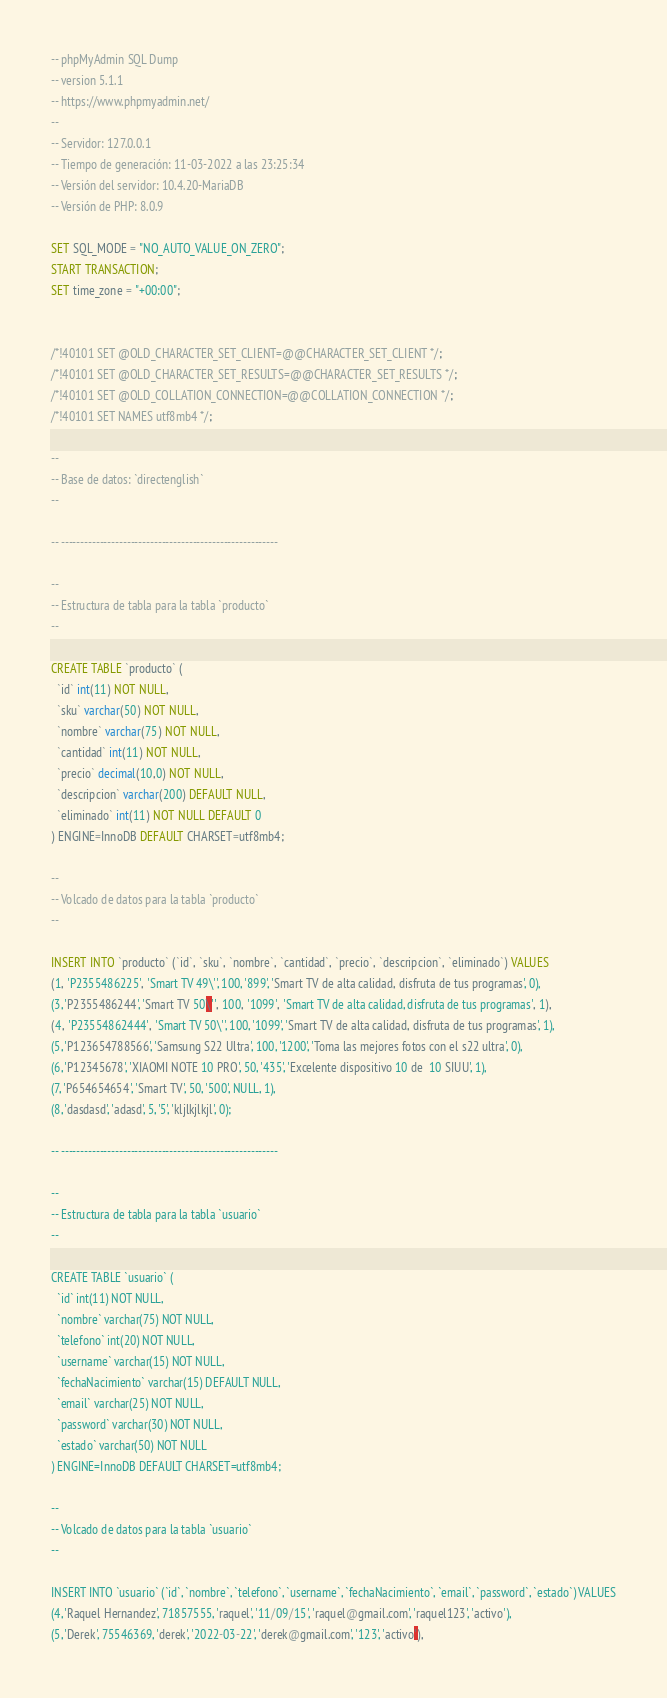Convert code to text. <code><loc_0><loc_0><loc_500><loc_500><_SQL_>-- phpMyAdmin SQL Dump
-- version 5.1.1
-- https://www.phpmyadmin.net/
--
-- Servidor: 127.0.0.1
-- Tiempo de generación: 11-03-2022 a las 23:25:34
-- Versión del servidor: 10.4.20-MariaDB
-- Versión de PHP: 8.0.9

SET SQL_MODE = "NO_AUTO_VALUE_ON_ZERO";
START TRANSACTION;
SET time_zone = "+00:00";


/*!40101 SET @OLD_CHARACTER_SET_CLIENT=@@CHARACTER_SET_CLIENT */;
/*!40101 SET @OLD_CHARACTER_SET_RESULTS=@@CHARACTER_SET_RESULTS */;
/*!40101 SET @OLD_COLLATION_CONNECTION=@@COLLATION_CONNECTION */;
/*!40101 SET NAMES utf8mb4 */;

--
-- Base de datos: `directenglish`
--

-- --------------------------------------------------------

--
-- Estructura de tabla para la tabla `producto`
--

CREATE TABLE `producto` (
  `id` int(11) NOT NULL,
  `sku` varchar(50) NOT NULL,
  `nombre` varchar(75) NOT NULL,
  `cantidad` int(11) NOT NULL,
  `precio` decimal(10,0) NOT NULL,
  `descripcion` varchar(200) DEFAULT NULL,
  `eliminado` int(11) NOT NULL DEFAULT 0
) ENGINE=InnoDB DEFAULT CHARSET=utf8mb4;

--
-- Volcado de datos para la tabla `producto`
--

INSERT INTO `producto` (`id`, `sku`, `nombre`, `cantidad`, `precio`, `descripcion`, `eliminado`) VALUES
(1, 'P2355486225', 'Smart TV 49\'', 100, '899', 'Smart TV de alta calidad, disfruta de tus programas', 0),
(3, 'P2355486244', 'Smart TV 50\'', 100, '1099', 'Smart TV de alta calidad, disfruta de tus programas', 1),
(4, 'P23554862444', 'Smart TV 50\'', 100, '1099', 'Smart TV de alta calidad, disfruta de tus programas', 1),
(5, 'P123654788566', 'Samsung S22 Ultra', 100, '1200', 'Toma las mejores fotos con el s22 ultra', 0),
(6, 'P12345678', 'XIAOMI NOTE 10 PRO', 50, '435', 'Excelente dispositivo 10 de  10 SIUU', 1),
(7, 'P654654654', 'Smart TV', 50, '500', NULL, 1),
(8, 'dasdasd', 'adasd', 5, '5', 'kljlkjlkjl', 0);

-- --------------------------------------------------------

--
-- Estructura de tabla para la tabla `usuario`
--

CREATE TABLE `usuario` (
  `id` int(11) NOT NULL,
  `nombre` varchar(75) NOT NULL,
  `telefono` int(20) NOT NULL,
  `username` varchar(15) NOT NULL,
  `fechaNacimiento` varchar(15) DEFAULT NULL,
  `email` varchar(25) NOT NULL,
  `password` varchar(30) NOT NULL,
  `estado` varchar(50) NOT NULL
) ENGINE=InnoDB DEFAULT CHARSET=utf8mb4;

--
-- Volcado de datos para la tabla `usuario`
--

INSERT INTO `usuario` (`id`, `nombre`, `telefono`, `username`, `fechaNacimiento`, `email`, `password`, `estado`) VALUES
(4, 'Raquel Hernandez', 71857555, 'raquel', '11/09/15', 'raquel@gmail.com', 'raquel123', 'activo'),
(5, 'Derek', 75546369, 'derek', '2022-03-22', 'derek@gmail.com', '123', 'activo'),</code> 